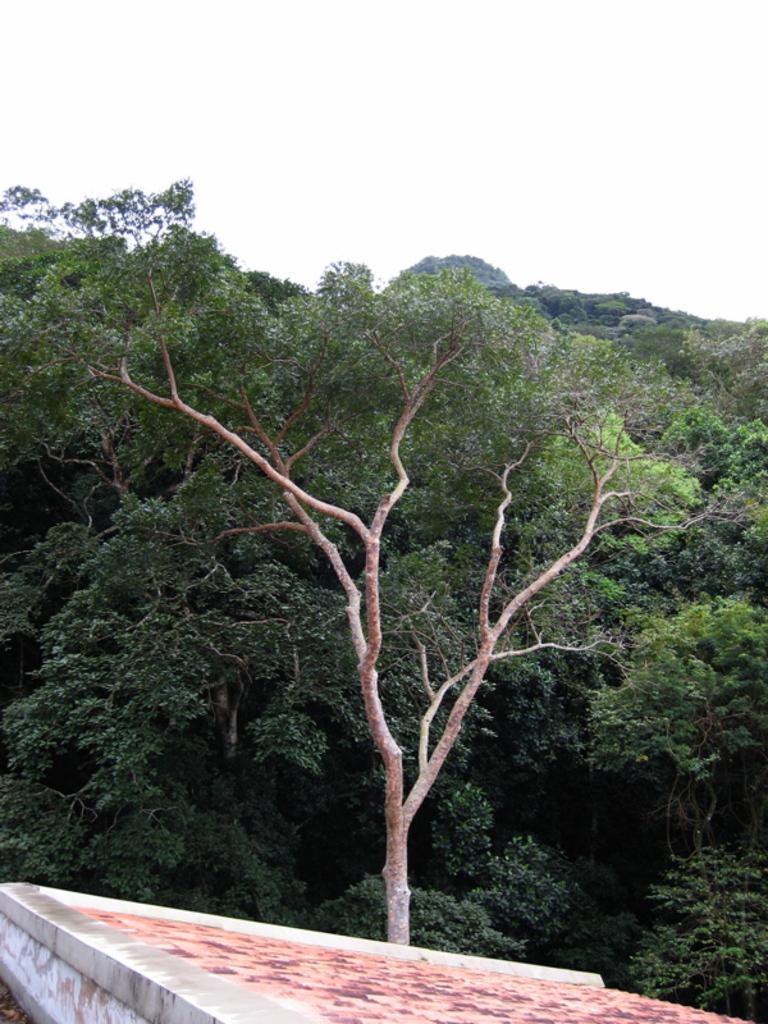Could you give a brief overview of what you see in this image? In this image at the bottom there is slope and wall, and in the background there are some trees. At the top there is sky. 